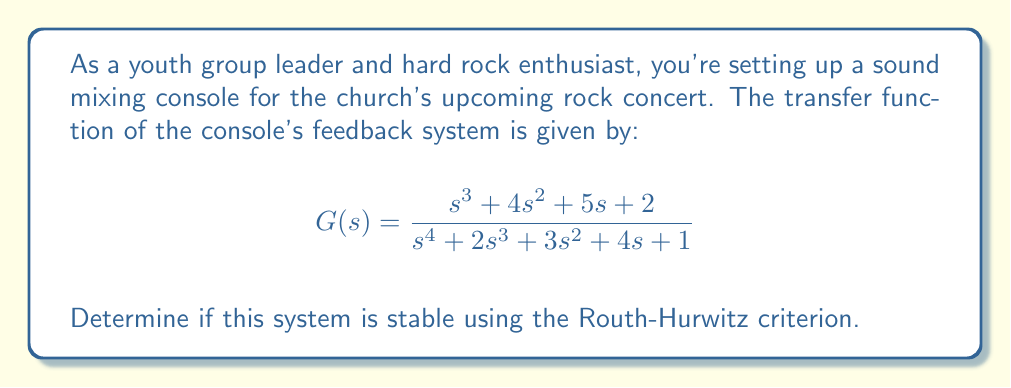Solve this math problem. To determine the stability of the system using the Routh-Hurwitz criterion, we need to construct the Routh array and analyze it. Here's the step-by-step process:

1. Write the characteristic equation:
   $$s^4 + 2s^3 + 3s^2 + 4s + 1 = 0$$

2. Construct the Routh array:

   $$\begin{array}{c|cc}
   s^4 & 1 & 3 & 1 \\
   s^3 & 2 & 4 & 0 \\
   s^2 & b_1 & b_2 & 0 \\
   s^1 & c_1 & 0 & 0 \\
   s^0 & d_1 & 0 & 0
   \end{array}$$

3. Calculate the values for $b_1$, $b_2$, $c_1$, and $d_1$:

   $$b_1 = \frac{(2)(3) - (1)(4)}{2} = 1$$
   $$b_2 = \frac{(2)(1) - (1)(0)}{2} = 1$$
   $$c_1 = \frac{(1)(4) - (2)(1)}{1} = 2$$
   $$d_1 = \frac{(2)(1) - (1)(0)}{2} = 1$$

4. The complete Routh array:

   $$\begin{array}{c|cc}
   s^4 & 1 & 3 & 1 \\
   s^3 & 2 & 4 & 0 \\
   s^2 & 1 & 1 & 0 \\
   s^1 & 2 & 0 & 0 \\
   s^0 & 1 & 0 & 0
   \end{array}$$

5. Analyze the first column of the Routh array:
   All elements in the first column (1, 2, 1, 2, 1) are positive and non-zero.

According to the Routh-Hurwitz criterion, a system is stable if and only if all elements in the first column of the Routh array are positive and non-zero. Since this condition is met in our case, the system is stable.
Answer: The sound mixing console system is stable. 